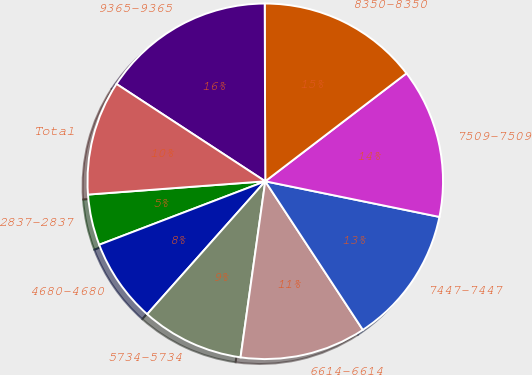Convert chart. <chart><loc_0><loc_0><loc_500><loc_500><pie_chart><fcel>2837-2837<fcel>4680-4680<fcel>5734-5734<fcel>6614-6614<fcel>7447-7447<fcel>7509-7509<fcel>8350-8350<fcel>9365-9365<fcel>Total<nl><fcel>4.62%<fcel>7.63%<fcel>9.34%<fcel>11.47%<fcel>12.54%<fcel>13.6%<fcel>14.66%<fcel>15.73%<fcel>10.41%<nl></chart> 